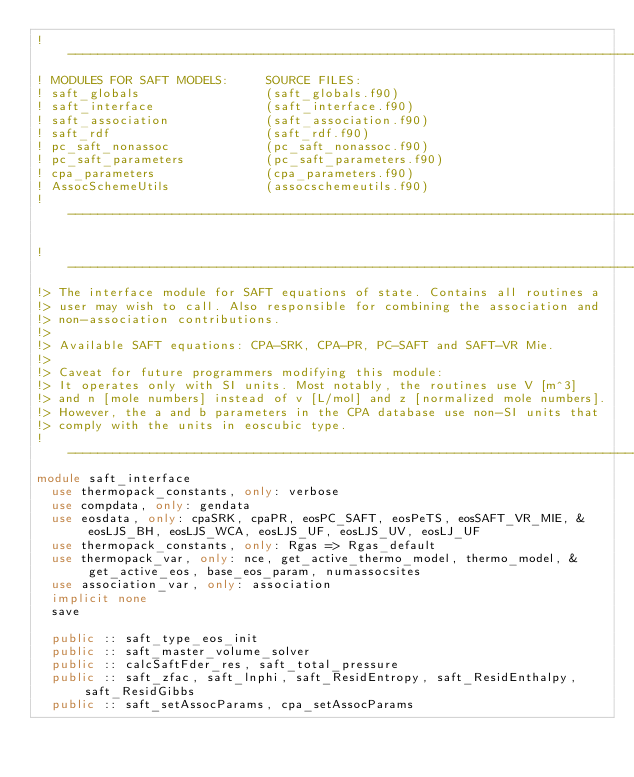Convert code to text. <code><loc_0><loc_0><loc_500><loc_500><_FORTRAN_>!------------------------------------------------------------------------------
! MODULES FOR SAFT MODELS:     SOURCE FILES:
! saft_globals                 (saft_globals.f90)
! saft_interface               (saft_interface.f90)
! saft_association             (saft_association.f90)
! saft_rdf                     (saft_rdf.f90)
! pc_saft_nonassoc             (pc_saft_nonassoc.f90)
! pc_saft_parameters           (pc_saft_parameters.f90)
! cpa_parameters               (cpa_parameters.f90)
! AssocSchemeUtils             (assocschemeutils.f90)
!------------------------------------------------------------------------------

!------------------------------------------------------------------------------
!> The interface module for SAFT equations of state. Contains all routines a
!> user may wish to call. Also responsible for combining the association and
!> non-association contributions.
!>
!> Available SAFT equations: CPA-SRK, CPA-PR, PC-SAFT and SAFT-VR Mie.
!>
!> Caveat for future programmers modifying this module:
!> It operates only with SI units. Most notably, the routines use V [m^3]
!> and n [mole numbers] instead of v [L/mol] and z [normalized mole numbers].
!> However, the a and b parameters in the CPA database use non-SI units that
!> comply with the units in eoscubic type.
!------------------------------------------------------------------------------
module saft_interface
  use thermopack_constants, only: verbose
  use compdata, only: gendata
  use eosdata, only: cpaSRK, cpaPR, eosPC_SAFT, eosPeTS, eosSAFT_VR_MIE, &
       eosLJS_BH, eosLJS_WCA, eosLJS_UF, eosLJS_UV, eosLJ_UF
  use thermopack_constants, only: Rgas => Rgas_default
  use thermopack_var, only: nce, get_active_thermo_model, thermo_model, &
       get_active_eos, base_eos_param, numassocsites
  use association_var, only: association
  implicit none
  save

  public :: saft_type_eos_init
  public :: saft_master_volume_solver
  public :: calcSaftFder_res, saft_total_pressure
  public :: saft_zfac, saft_lnphi, saft_ResidEntropy, saft_ResidEnthalpy, saft_ResidGibbs
  public :: saft_setAssocParams, cpa_setAssocParams</code> 